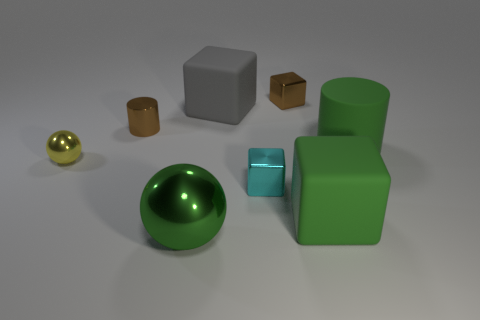Subtract all blue cubes. Subtract all yellow cylinders. How many cubes are left? 4 Add 1 tiny yellow rubber cylinders. How many objects exist? 9 Subtract all balls. How many objects are left? 6 Add 2 brown cylinders. How many brown cylinders are left? 3 Add 5 metallic cylinders. How many metallic cylinders exist? 6 Subtract 0 cyan cylinders. How many objects are left? 8 Subtract all large red rubber cubes. Subtract all large green blocks. How many objects are left? 7 